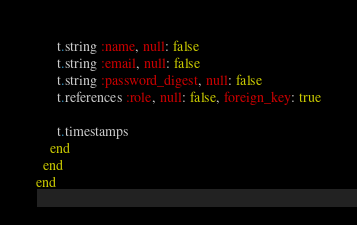<code> <loc_0><loc_0><loc_500><loc_500><_Ruby_>      t.string :name, null: false
      t.string :email, null: false
      t.string :password_digest, null: false
      t.references :role, null: false, foreign_key: true

      t.timestamps
    end
  end
end
</code> 